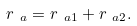Convert formula to latex. <formula><loc_0><loc_0><loc_500><loc_500>r _ { \ a } = r _ { \ a 1 } + r _ { \ a 2 } .</formula> 